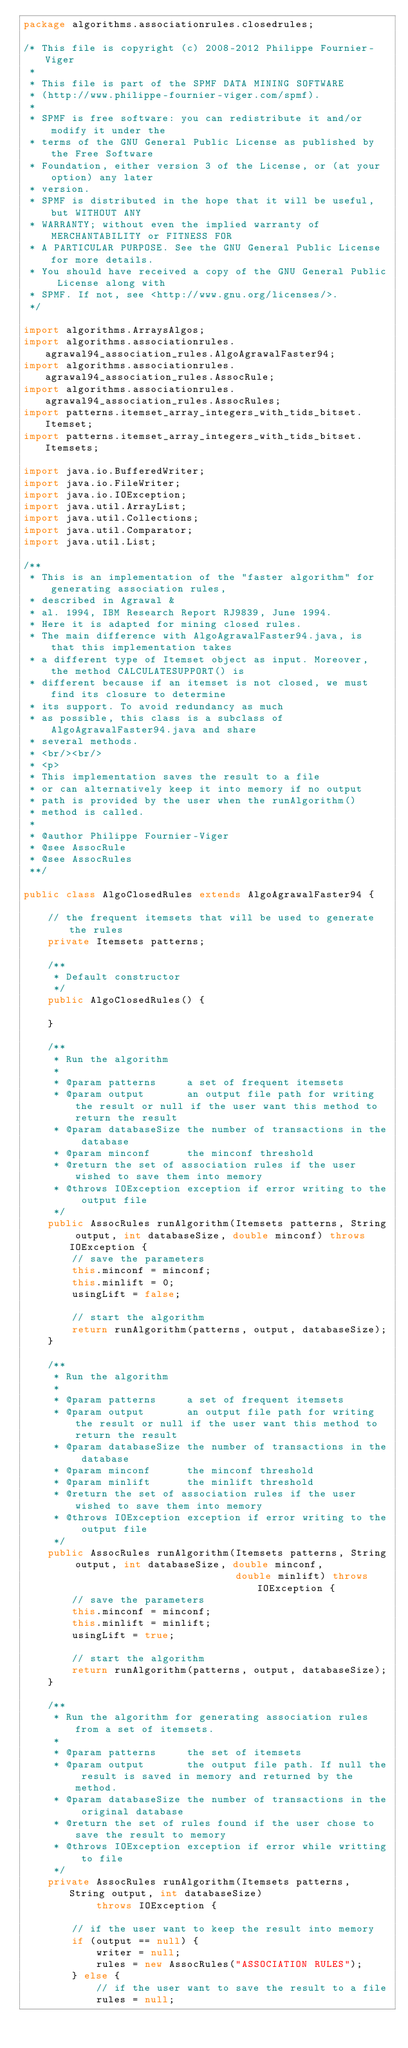Convert code to text. <code><loc_0><loc_0><loc_500><loc_500><_Java_>package algorithms.associationrules.closedrules;

/* This file is copyright (c) 2008-2012 Philippe Fournier-Viger
 *
 * This file is part of the SPMF DATA MINING SOFTWARE
 * (http://www.philippe-fournier-viger.com/spmf).
 *
 * SPMF is free software: you can redistribute it and/or modify it under the
 * terms of the GNU General Public License as published by the Free Software
 * Foundation, either version 3 of the License, or (at your option) any later
 * version.
 * SPMF is distributed in the hope that it will be useful, but WITHOUT ANY
 * WARRANTY; without even the implied warranty of MERCHANTABILITY or FITNESS FOR
 * A PARTICULAR PURPOSE. See the GNU General Public License for more details.
 * You should have received a copy of the GNU General Public License along with
 * SPMF. If not, see <http://www.gnu.org/licenses/>.
 */

import algorithms.ArraysAlgos;
import algorithms.associationrules.agrawal94_association_rules.AlgoAgrawalFaster94;
import algorithms.associationrules.agrawal94_association_rules.AssocRule;
import algorithms.associationrules.agrawal94_association_rules.AssocRules;
import patterns.itemset_array_integers_with_tids_bitset.Itemset;
import patterns.itemset_array_integers_with_tids_bitset.Itemsets;

import java.io.BufferedWriter;
import java.io.FileWriter;
import java.io.IOException;
import java.util.ArrayList;
import java.util.Collections;
import java.util.Comparator;
import java.util.List;

/**
 * This is an implementation of the "faster algorithm" for generating association rules,
 * described in Agrawal &
 * al. 1994, IBM Research Report RJ9839, June 1994.
 * Here it is adapted for mining closed rules.
 * The main difference with AlgoAgrawalFaster94.java, is that this implementation takes
 * a different type of Itemset object as input. Moreover, the method CALCULATESUPPORT() is
 * different because if an itemset is not closed, we must find its closure to determine
 * its support. To avoid redundancy as much
 * as possible, this class is a subclass of AlgoAgrawalFaster94.java and share
 * several methods.
 * <br/><br/>
 * <p>
 * This implementation saves the result to a file
 * or can alternatively keep it into memory if no output
 * path is provided by the user when the runAlgorithm()
 * method is called.
 *
 * @author Philippe Fournier-Viger
 * @see AssocRule
 * @see AssocRules
 **/

public class AlgoClosedRules extends AlgoAgrawalFaster94 {

    // the frequent itemsets that will be used to generate the rules
    private Itemsets patterns;

    /**
     * Default constructor
     */
    public AlgoClosedRules() {

    }

    /**
     * Run the algorithm
     *
     * @param patterns     a set of frequent itemsets
     * @param output       an output file path for writing the result or null if the user want this method to return the result
     * @param databaseSize the number of transactions in the database
     * @param minconf      the minconf threshold
     * @return the set of association rules if the user wished to save them into memory
     * @throws IOException exception if error writing to the output file
     */
    public AssocRules runAlgorithm(Itemsets patterns, String output, int databaseSize, double minconf) throws IOException {
        // save the parameters
        this.minconf = minconf;
        this.minlift = 0;
        usingLift = false;

        // start the algorithm
        return runAlgorithm(patterns, output, databaseSize);
    }

    /**
     * Run the algorithm
     *
     * @param patterns     a set of frequent itemsets
     * @param output       an output file path for writing the result or null if the user want this method to return the result
     * @param databaseSize the number of transactions in the database
     * @param minconf      the minconf threshold
     * @param minlift      the minlift threshold
     * @return the set of association rules if the user wished to save them into memory
     * @throws IOException exception if error writing to the output file
     */
    public AssocRules runAlgorithm(Itemsets patterns, String output, int databaseSize, double minconf,
                                   double minlift) throws IOException {
        // save the parameters
        this.minconf = minconf;
        this.minlift = minlift;
        usingLift = true;

        // start the algorithm
        return runAlgorithm(patterns, output, databaseSize);
    }

    /**
     * Run the algorithm for generating association rules from a set of itemsets.
     *
     * @param patterns     the set of itemsets
     * @param output       the output file path. If null the result is saved in memory and returned by the method.
     * @param databaseSize the number of transactions in the original database
     * @return the set of rules found if the user chose to save the result to memory
     * @throws IOException exception if error while writting to file
     */
    private AssocRules runAlgorithm(Itemsets patterns, String output, int databaseSize)
            throws IOException {

        // if the user want to keep the result into memory
        if (output == null) {
            writer = null;
            rules = new AssocRules("ASSOCIATION RULES");
        } else {
            // if the user want to save the result to a file
            rules = null;</code> 